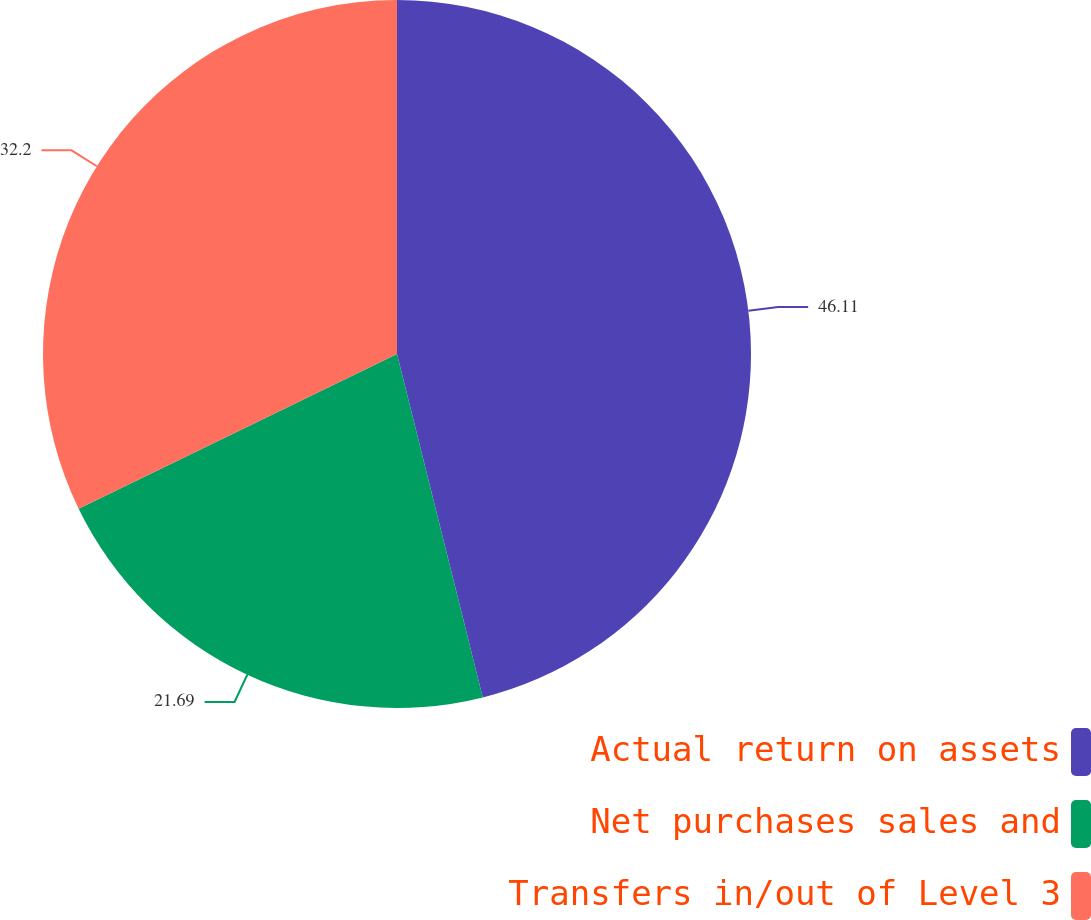<chart> <loc_0><loc_0><loc_500><loc_500><pie_chart><fcel>Actual return on assets<fcel>Net purchases sales and<fcel>Transfers in/out of Level 3<nl><fcel>46.1%<fcel>21.69%<fcel>32.2%<nl></chart> 